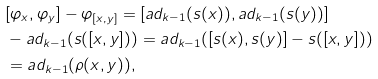<formula> <loc_0><loc_0><loc_500><loc_500>& [ \varphi _ { x } , \varphi _ { y } ] - \varphi _ { [ x , y ] } = [ a d _ { k - 1 } ( s ( x ) ) , a d _ { k - 1 } ( s ( y ) ) ] \\ & - a d _ { k - 1 } ( s ( [ x , y ] ) ) = a d _ { k - 1 } ( [ s ( x ) , s ( y ) ] - s ( [ x , y ] ) ) \\ & = a d _ { k - 1 } ( \rho ( x , y ) ) ,</formula> 